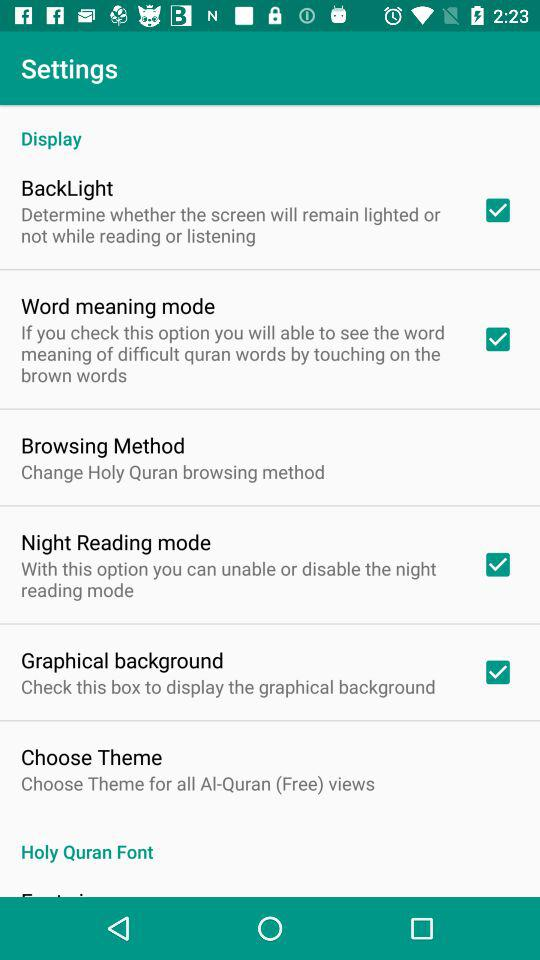What is the status of "BackLight"? The status of "BackLight" is "on". 